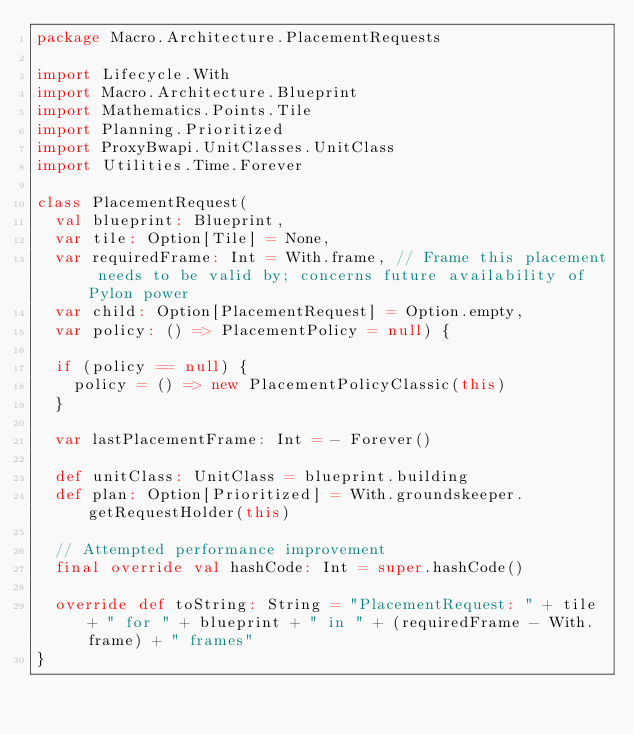<code> <loc_0><loc_0><loc_500><loc_500><_Scala_>package Macro.Architecture.PlacementRequests

import Lifecycle.With
import Macro.Architecture.Blueprint
import Mathematics.Points.Tile
import Planning.Prioritized
import ProxyBwapi.UnitClasses.UnitClass
import Utilities.Time.Forever

class PlacementRequest(
  val blueprint: Blueprint,
  var tile: Option[Tile] = None,
  var requiredFrame: Int = With.frame, // Frame this placement needs to be valid by; concerns future availability of Pylon power
  var child: Option[PlacementRequest] = Option.empty,
  var policy: () => PlacementPolicy = null) {

  if (policy == null) {
    policy = () => new PlacementPolicyClassic(this)
  }

  var lastPlacementFrame: Int = - Forever()

  def unitClass: UnitClass = blueprint.building
  def plan: Option[Prioritized] = With.groundskeeper.getRequestHolder(this)

  // Attempted performance improvement
  final override val hashCode: Int = super.hashCode()

  override def toString: String = "PlacementRequest: " + tile + " for " + blueprint + " in " + (requiredFrame - With.frame) + " frames"
}</code> 